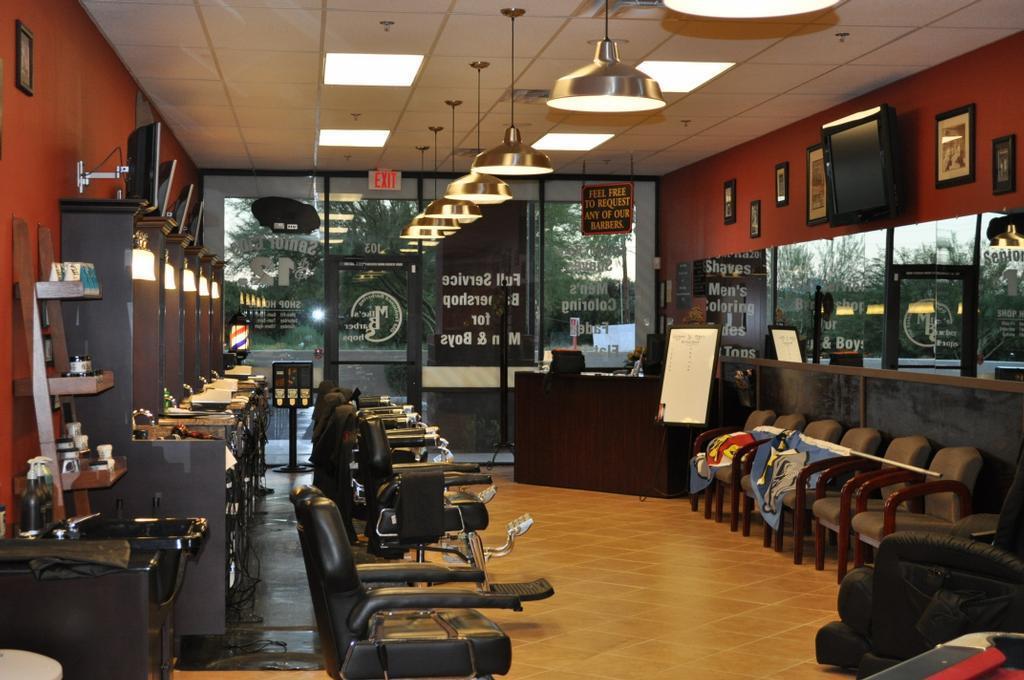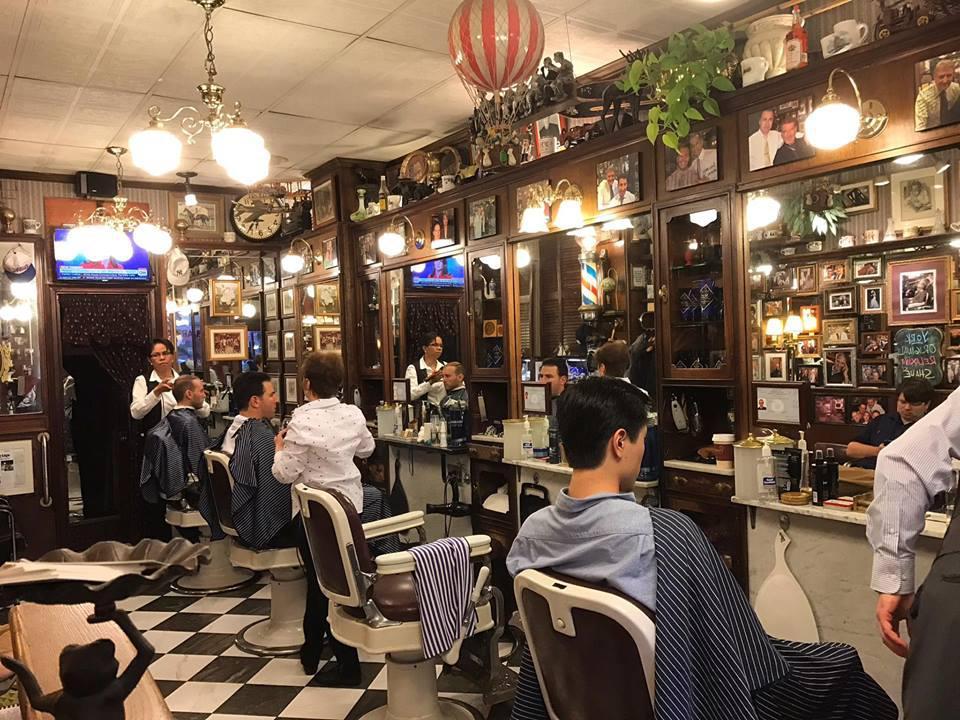The first image is the image on the left, the second image is the image on the right. Assess this claim about the two images: "In at least one image there is a single man posing in the middle of a barber shop.". Correct or not? Answer yes or no. No. The first image is the image on the left, the second image is the image on the right. Evaluate the accuracy of this statement regarding the images: "An image includes a row of empty rightward-facing black barber chairs under a row of lights.". Is it true? Answer yes or no. Yes. 